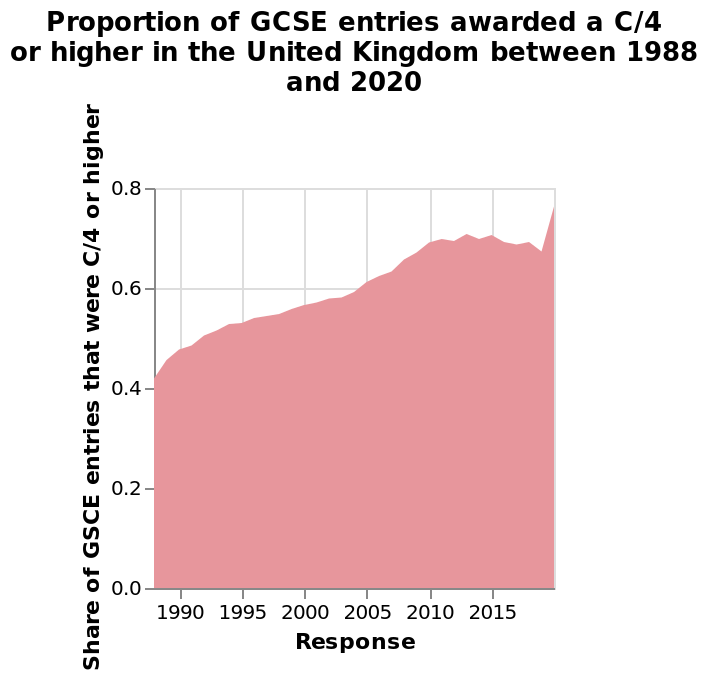<image>
What does the area plot represent in the context of GCSE entries in the United Kingdom? The area plot represents the proportion of GCSE entries awarded a C/4 or higher in the United Kingdom between 1988 and 2020. Can you describe the overall pattern of the numbers? The numbers showed a slight upward trend to 2010, followed by more level numbers, and then a sharp rise in 2019. 